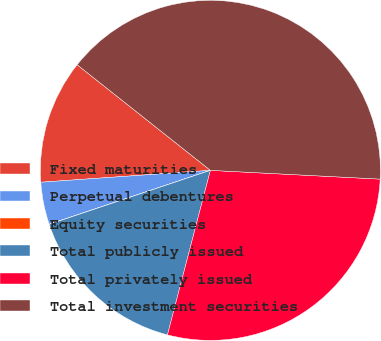<chart> <loc_0><loc_0><loc_500><loc_500><pie_chart><fcel>Fixed maturities<fcel>Perpetual debentures<fcel>Equity securities<fcel>Total publicly issued<fcel>Total privately issued<fcel>Total investment securities<nl><fcel>11.78%<fcel>4.02%<fcel>0.01%<fcel>15.79%<fcel>28.24%<fcel>40.15%<nl></chart> 